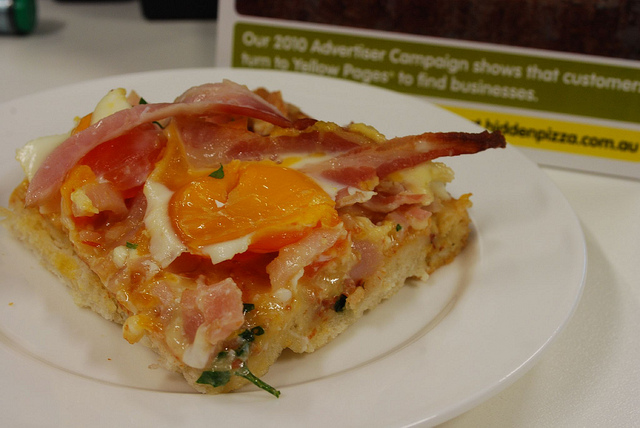<image>Is this an Australian pizza place? It's ambiguous if this is an Australian pizza place. Is this an Australian pizza place? I don't know if this is an Australian pizza place. It seems to be a mix of yes and no answers. 